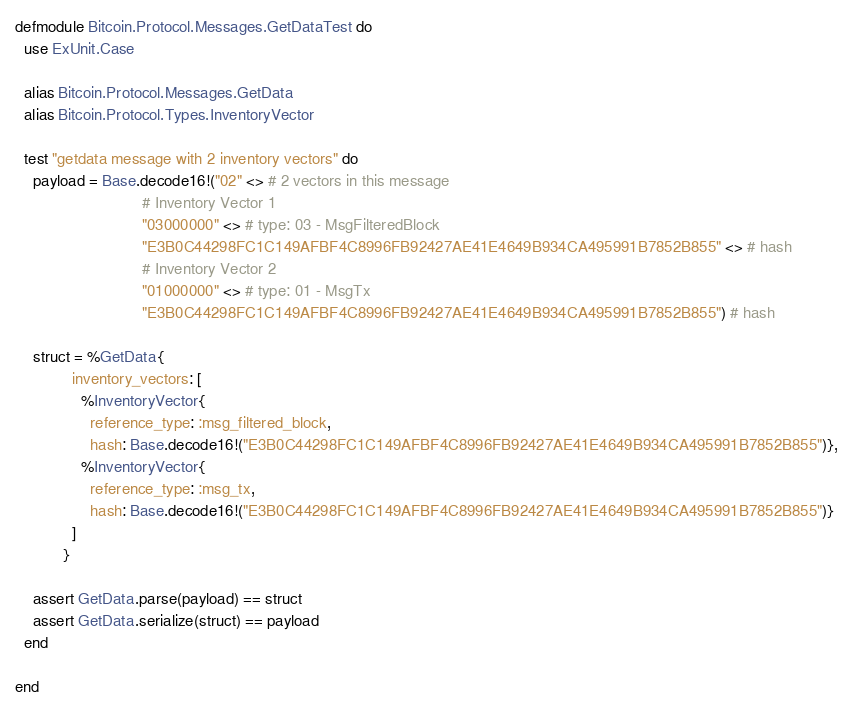Convert code to text. <code><loc_0><loc_0><loc_500><loc_500><_Elixir_>defmodule Bitcoin.Protocol.Messages.GetDataTest do
  use ExUnit.Case

  alias Bitcoin.Protocol.Messages.GetData
  alias Bitcoin.Protocol.Types.InventoryVector

  test "getdata message with 2 inventory vectors" do
    payload = Base.decode16!("02" <> # 2 vectors in this message
                             # Inventory Vector 1
                             "03000000" <> # type: 03 - MsgFilteredBlock
                             "E3B0C44298FC1C149AFBF4C8996FB92427AE41E4649B934CA495991B7852B855" <> # hash
                             # Inventory Vector 2
                             "01000000" <> # type: 01 - MsgTx
                             "E3B0C44298FC1C149AFBF4C8996FB92427AE41E4649B934CA495991B7852B855") # hash

    struct = %GetData{
             inventory_vectors: [
               %InventoryVector{
                 reference_type: :msg_filtered_block,
                 hash: Base.decode16!("E3B0C44298FC1C149AFBF4C8996FB92427AE41E4649B934CA495991B7852B855")},
               %InventoryVector{
                 reference_type: :msg_tx,
                 hash: Base.decode16!("E3B0C44298FC1C149AFBF4C8996FB92427AE41E4649B934CA495991B7852B855")}
             ]
           }

    assert GetData.parse(payload) == struct
    assert GetData.serialize(struct) == payload
  end

end
</code> 